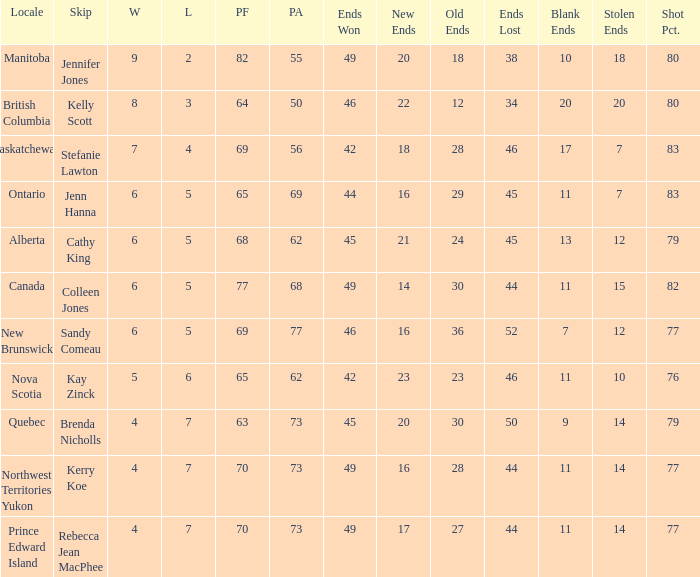What is the lowest PF? 63.0. 